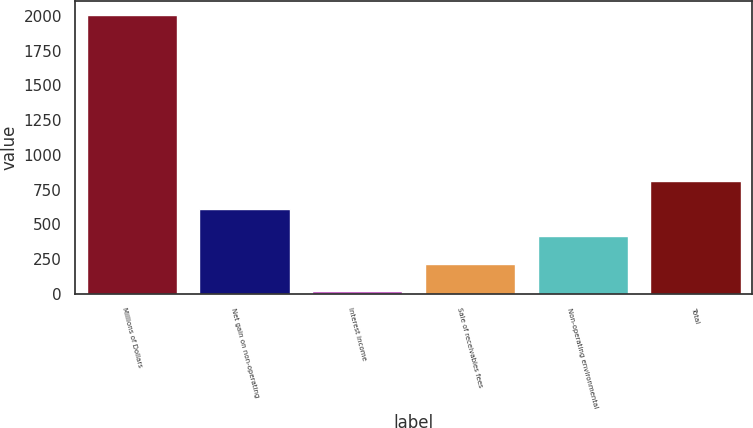<chart> <loc_0><loc_0><loc_500><loc_500><bar_chart><fcel>Millions of Dollars<fcel>Net gain on non-operating<fcel>Interest income<fcel>Sale of receivables fees<fcel>Non-operating environmental<fcel>Total<nl><fcel>2005<fcel>613.4<fcel>17<fcel>215.8<fcel>414.6<fcel>812.2<nl></chart> 